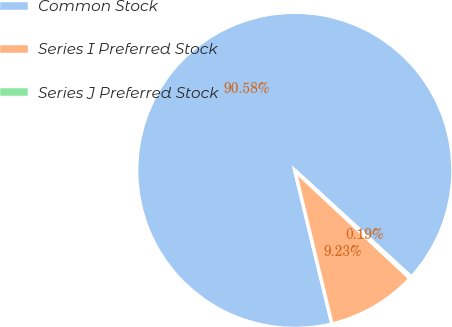<chart> <loc_0><loc_0><loc_500><loc_500><pie_chart><fcel>Common Stock<fcel>Series I Preferred Stock<fcel>Series J Preferred Stock<nl><fcel>90.58%<fcel>9.23%<fcel>0.19%<nl></chart> 